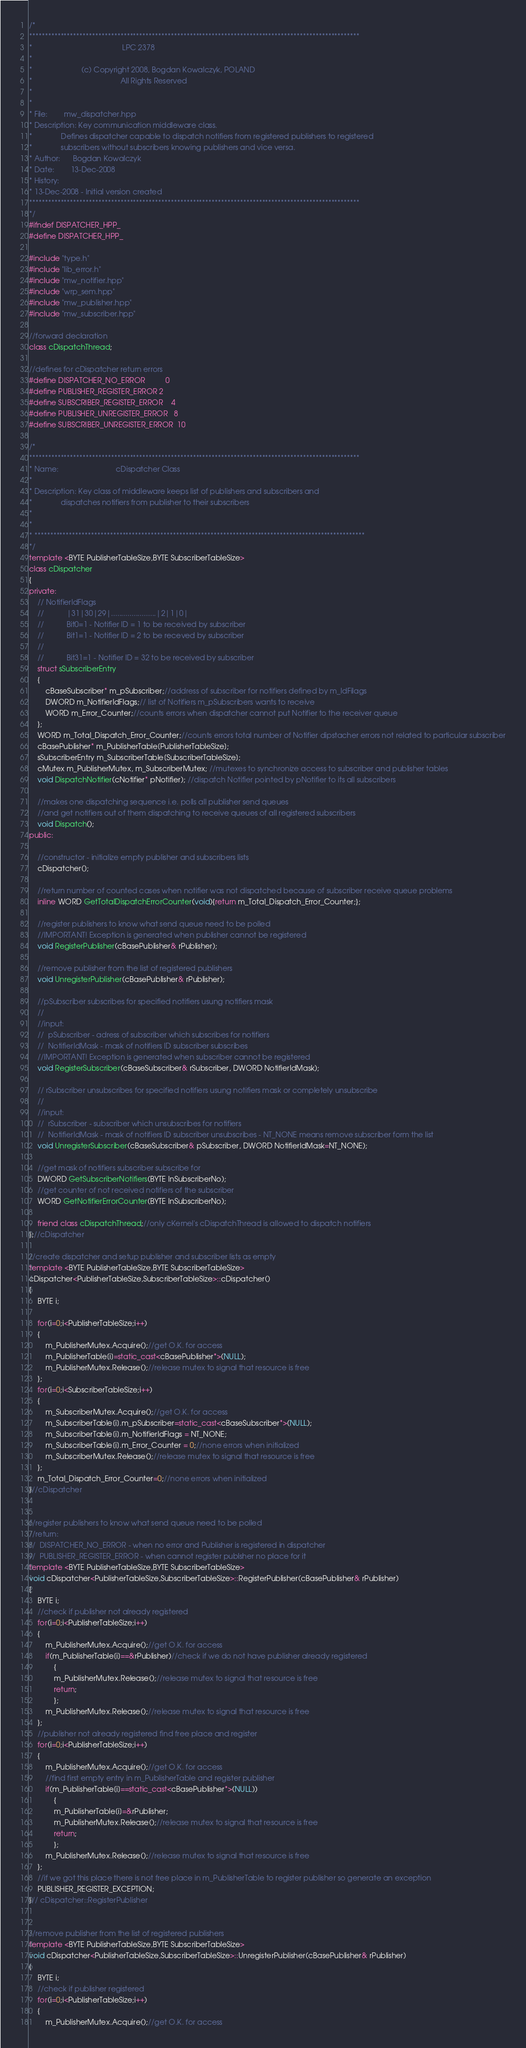Convert code to text. <code><loc_0><loc_0><loc_500><loc_500><_C++_>/*
*********************************************************************************************************
*                                            LPC 2378
*
*                        (c) Copyright 2008, Bogdan Kowalczyk, POLAND
*                                           All Rights Reserved
*
*
* File:        mw_dispatcher.hpp
* Description: Key communication middleware class.
*              Defines dispatcher capable to dispatch notifiers from registered publishers to registered
*              subscribers without subscribers knowing publishers and vice versa.
* Author:      Bogdan Kowalczyk
* Date:        13-Dec-2008
* History:
* 13-Dec-2008 - Initial version created
*********************************************************************************************************
*/
#ifndef DISPATCHER_HPP_
#define DISPATCHER_HPP_

#include "type.h"
#include "lib_error.h"
#include "mw_notifier.hpp"
#include "wrp_sem.hpp"
#include "mw_publisher.hpp"
#include "mw_subscriber.hpp"

//forward declaration
class cDispatchThread;

//defines for cDispatcher return errors
#define DISPATCHER_NO_ERROR			0
#define PUBLISHER_REGISTER_ERROR	2
#define SUBSCRIBER_REGISTER_ERROR	4
#define PUBLISHER_UNREGISTER_ERROR	8
#define SUBSCRIBER_UNREGISTER_ERROR	10

/*
*********************************************************************************************************
* Name:                            cDispatcher Class 
* 
* Description: Key class of middleware keeps list of publishers and subscribers and
*              dispatches notifiers from publisher to their subscribers
*       
*
* *********************************************************************************************************
*/
template <BYTE PublisherTableSize,BYTE SubscriberTableSize> 
class cDispatcher
{
private:
	// NotifierIdFlags
	//           |31|30|29|......................|2|1|0|
	//           Bit0=1 - Notifier ID = 1 to be received by subscriber
	//           Bit1=1 - Notifier ID = 2 to be receved by subscriber
	//
	//           Bit31=1 - Notifier ID = 32 to be received by subscriber
	struct sSubscriberEntry
	{
		cBaseSubscriber* m_pSubscriber;//address of subscriber for notifiers defined by m_IdFilags 
		DWORD m_NotifierIdFlags;// list of Notifiers m_pSubscribers wants to receive
		WORD m_Error_Counter;//counts errors when dispatcher cannot put Notifier to the receiver queue
	};
	WORD m_Total_Dispatch_Error_Counter;//counts errors total number of Notifier dipstacher errors not related to particular subscriber
	cBasePublisher* m_PublisherTable[PublisherTableSize];
	sSubscriberEntry m_SubscriberTable[SubscriberTableSize];
	cMutex m_PublisherMutex, m_SubscriberMutex; //mutexes to synchronize access to subscriber and publisher tables
	void DispatchNotifier(cNotifier* pNotifier); //dispatch Notifier pointed by pNotifier to its all subscribers
	
	//makes one dispatching sequence i.e. polls all publisher send queues
	//and get notifiers out of them dispatching to receive queues of all registered subscribers
	void Dispatch();
public:
	
	//constructor - initialize empty publisher and subscribers lists
	cDispatcher();
	
	//return number of counted cases when notifier was not dispatched because of subscriber receive queue problems
	inline WORD GetTotalDispatchErrorCounter(void){return m_Total_Dispatch_Error_Counter;};
	
	//register publishers to know what send queue need to be polled
	//IMPORTANT! Exception is generated when publisher cannot be registered
	void RegisterPublisher(cBasePublisher& rPublisher);
	
	//remove publisher from the list of registered publishers
	void UnregisterPublisher(cBasePublisher& rPublisher);
	
	//pSubscriber subscribes for specified notifiers usung notifiers mask
	//
	//input:
	//	pSubscriber - adress of subscriber which subscribes for notifiers
	//  NotifierIdMask - mask of notifiers ID subscriber subscribes
	//IMPORTANT! Exception is generated when subscriber cannot be registered
	void RegisterSubscriber(cBaseSubscriber& rSubscriber, DWORD NotifierIdMask);
	
	// rSubscriber unsubscribes for specified notifiers usung notifiers mask or completely unsubscribe
	//
	//input:
	//	rSubscriber - subscriber which unsubscribes for notifiers
	//  NotifierIdMask - mask of notifiers ID subscriber unsubscribes - NT_NONE means remove subscriber form the list
	void UnregisterSubscriber(cBaseSubscriber& pSubscriber, DWORD NotifierIdMask=NT_NONE);
	
	//get mask of notifiers subscriber subscribe for
	DWORD GetSubscriberNotifiers(BYTE InSubscriberNo);
	//get counter of not received notifiers of the subscriber
	WORD GetNotifierErrorCounter(BYTE InSubscriberNo);
	
	friend class cDispatchThread;//only cKernel's cDispatchThread is allowed to dispatch notifiers
};//cDispatcher

//create dispatcher and setup publisher and subscriber lists as empty
template <BYTE PublisherTableSize,BYTE SubscriberTableSize>
cDispatcher<PublisherTableSize,SubscriberTableSize>::cDispatcher()
{
	BYTE i;

	for(i=0;i<PublisherTableSize;i++)
	{
		m_PublisherMutex.Acquire();//get O.K. for access
		m_PublisherTable[i]=static_cast<cBasePublisher*>(NULL);
		m_PublisherMutex.Release();//release mutex to signal that resource is free
	};
	for(i=0;i<SubscriberTableSize;i++)
	{
		m_SubscriberMutex.Acquire();//get O.K. for access
		m_SubscriberTable[i].m_pSubscriber=static_cast<cBaseSubscriber*>(NULL);
		m_SubscriberTable[i].m_NotifierIdFlags = NT_NONE;
		m_SubscriberTable[i].m_Error_Counter = 0;//none errors when initialized
		m_SubscriberMutex.Release();//release mutex to signal that resource is free
	};
	m_Total_Dispatch_Error_Counter=0;//none errors when initialized
}//cDispatcher


//register publishers to know what send queue need to be polled
//return:
//	DISPATCHER_NO_ERROR - when no error and Publisher is registered in dispatcher
//  PUBLISHER_REGISTER_ERROR - when cannot register publsher no place for it
template <BYTE PublisherTableSize,BYTE SubscriberTableSize>
void cDispatcher<PublisherTableSize,SubscriberTableSize>::RegisterPublisher(cBasePublisher& rPublisher)
{
	BYTE i;
	//check if publisher not already registered
	for(i=0;i<PublisherTableSize;i++)
	{
		m_PublisherMutex.Acquire();//get O.K. for access
		if(m_PublisherTable[i]==&rPublisher)//check if we do not have publisher already registered
			{
			m_PublisherMutex.Release();//release mutex to signal that resource is free
			return; 
			};
		m_PublisherMutex.Release();//release mutex to signal that resource is free
	};
	//publisher not already registered find free place and register
	for(i=0;i<PublisherTableSize;i++)
	{
		m_PublisherMutex.Acquire();//get O.K. for access
		//find first empty entry in m_PublisherTable and register publisher
		if(m_PublisherTable[i]==static_cast<cBasePublisher*>(NULL))
			{
			m_PublisherTable[i]=&rPublisher;
			m_PublisherMutex.Release();//release mutex to signal that resource is free
			return;
			};
		m_PublisherMutex.Release();//release mutex to signal that resource is free
	};
	//if we got this place there is not free place in m_PublisherTable to register publisher so generate an exception
	PUBLISHER_REGISTER_EXCEPTION;
}// cDispatcher::RegisterPublisher


//remove publisher from the list of registered publishers
template <BYTE PublisherTableSize,BYTE SubscriberTableSize>
void cDispatcher<PublisherTableSize,SubscriberTableSize>::UnregisterPublisher(cBasePublisher& rPublisher)
{
	BYTE i;
	//check if publisher registered
	for(i=0;i<PublisherTableSize;i++)
	{
		m_PublisherMutex.Acquire();//get O.K. for access</code> 